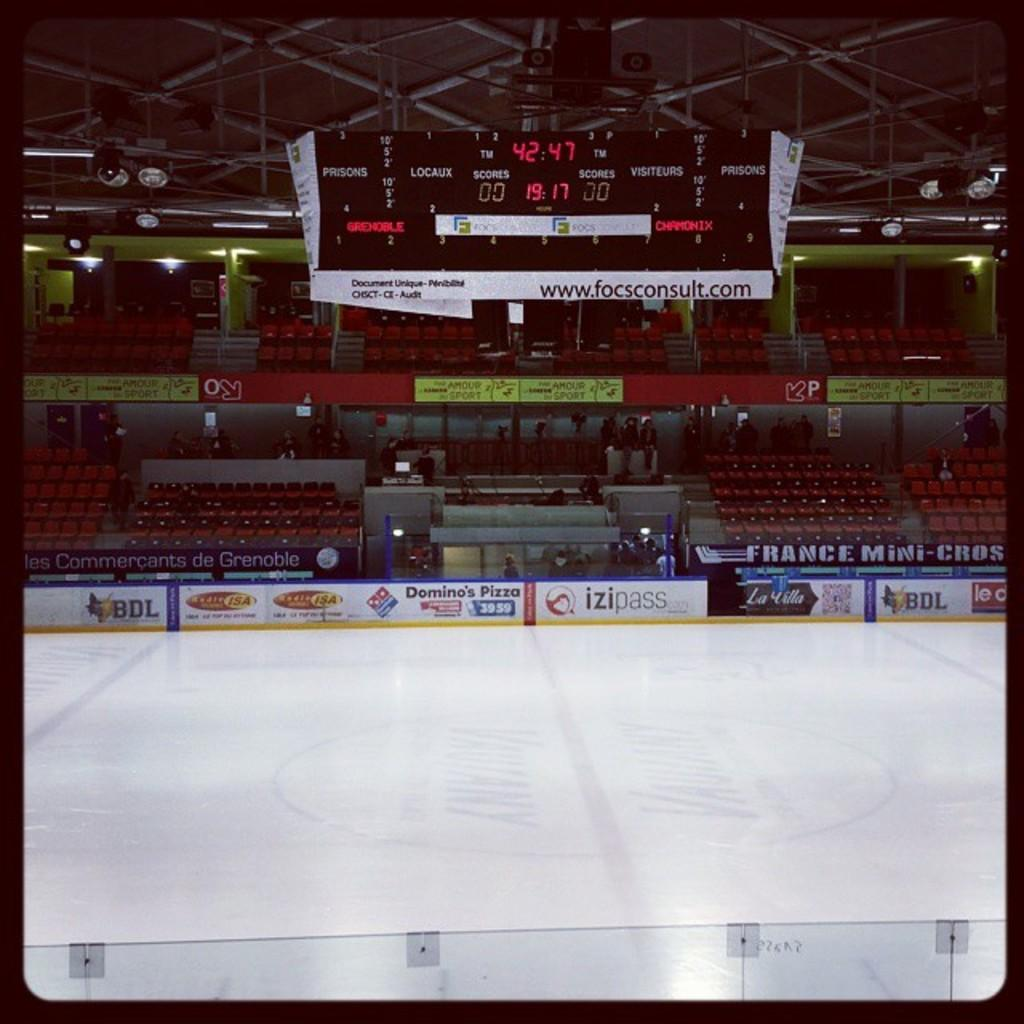Provide a one-sentence caption for the provided image. An empty ice hockey rink with a scoreboard showing a score of 0 to 0. 